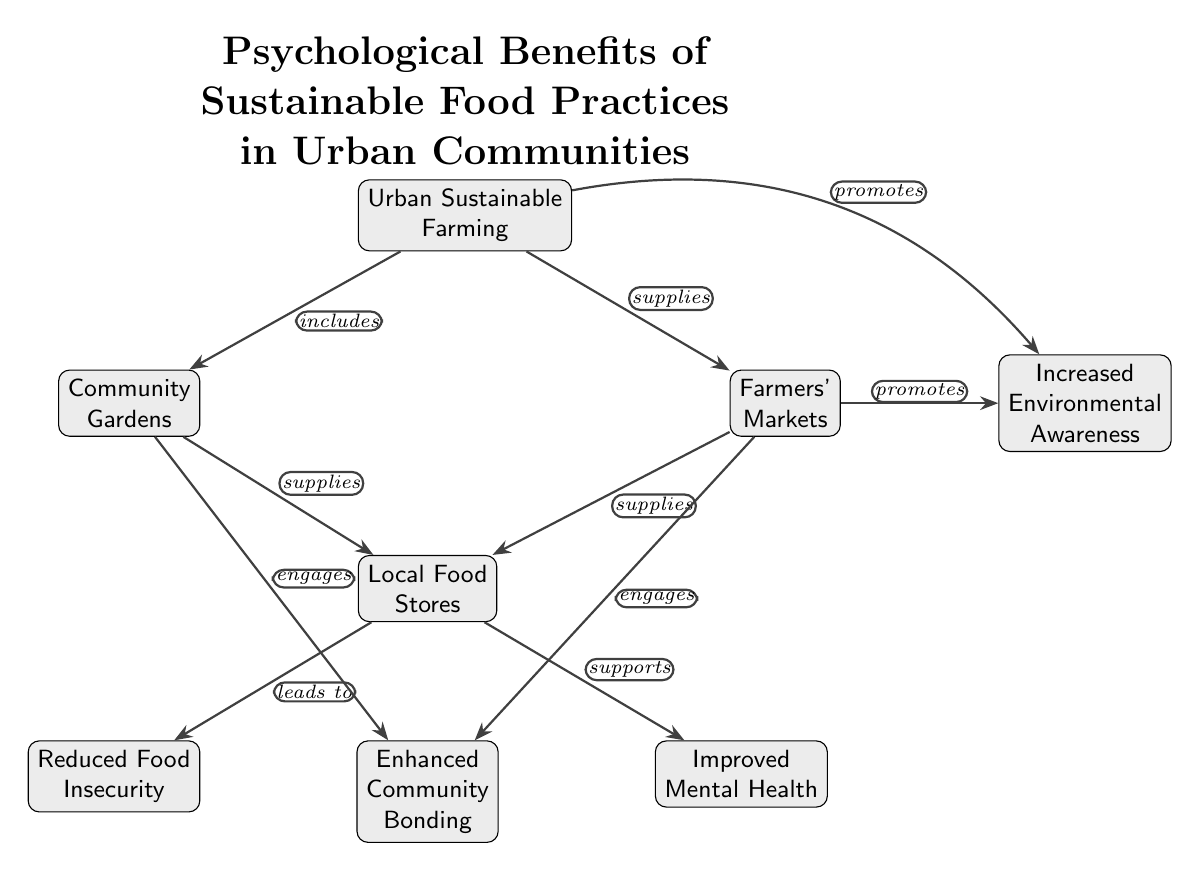What is the central concept of the diagram? The central concept is introduced at the top of the diagram as "Psychological Benefits of Sustainable Food Practices in Urban Communities." This represents the overarching theme that connects all other elements.
Answer: Psychological Benefits of Sustainable Food Practices in Urban Communities How many nodes are in the diagram? Counting each distinct element represented by nodes, we find a total of 9 nodes linked by edges.
Answer: 9 What two types of entities does Urban Sustainable Farming include? Urban Sustainable Farming includes Community Gardens and Farmers' Markets, as indicated by the edges that define these relationships.
Answer: Community Gardens and Farmers' Markets What does Community Gardens engage? The diagram shows that Community Gardens "engages" Enhanced Community Bonding through the directed edge, indicating a supportive relationship between these two elements.
Answer: Enhanced Community Bonding What does Local Food Stores lead to? The edge from Local Food Stores to Reduced Food Insecurity indicates a direct consequence or outcome, which clarifies that this node supports this benefit.
Answer: Reduced Food Insecurity How do Farmers' Markets promote Environmental Awareness? The diagram indicates that Farmers' Markets have a promoting relationship with Increased Environmental Awareness, as shown by the directed edge from Farmers' Markets to this concept.
Answer: Increased Environmental Awareness What supports Improved Mental Health? The diagram shows that Local Food Stores support Improved Mental Health, indicating a beneficial relationship that points towards mental well-being as a result of local food initiatives.
Answer: Improved Mental Health What benefits does Urban Sustainable Farming provide? Urban Sustainable Farming provides Community Gardens and Farmers' Markets, from which various psychological benefits flow down the diagram, such as enhanced bonding and awareness.
Answer: Community Gardens and Farmers' Markets How do Local Food Stores relate to Enhanced Community Bonding? The diagram illustrates that both Community Gardens and Farmers' Markets engage Enhanced Community Bonding, thus Local Food Stores indirectly contribute to this as they are supplied by the aforementioned nodes.
Answer: Indirectly contributes to Enhanced Community Bonding 